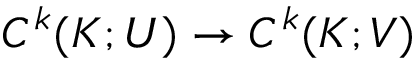Convert formula to latex. <formula><loc_0><loc_0><loc_500><loc_500>C ^ { k } ( K ; U ) \to C ^ { k } ( K ; V )</formula> 